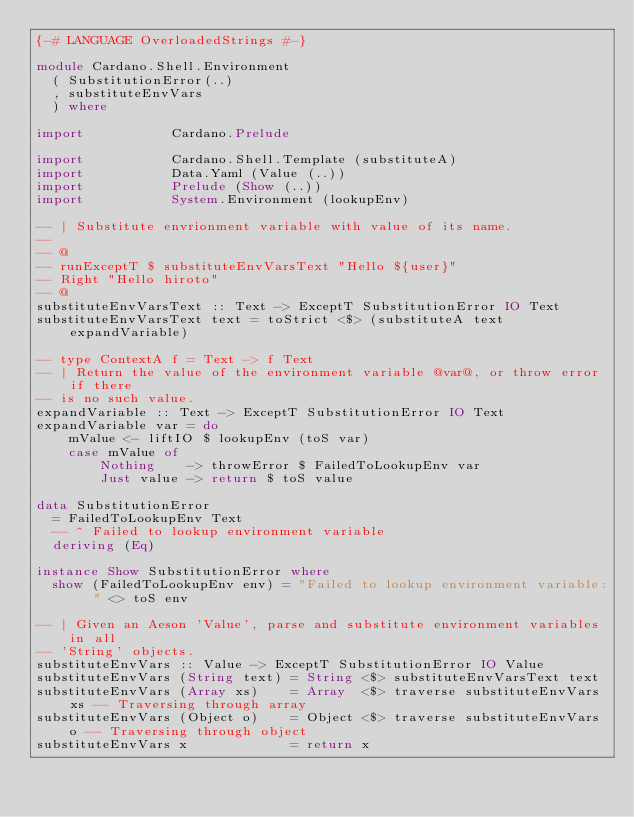Convert code to text. <code><loc_0><loc_0><loc_500><loc_500><_Haskell_>{-# LANGUAGE OverloadedStrings #-}

module Cardano.Shell.Environment
  ( SubstitutionError(..)
  , substituteEnvVars
  ) where

import           Cardano.Prelude

import           Cardano.Shell.Template (substituteA)
import           Data.Yaml (Value (..))
import           Prelude (Show (..))
import           System.Environment (lookupEnv)

-- | Substitute envrionment variable with value of its name.
--
-- @
-- runExceptT $ substituteEnvVarsText "Hello ${user}"
-- Right "Hello hiroto"
-- @
substituteEnvVarsText :: Text -> ExceptT SubstitutionError IO Text
substituteEnvVarsText text = toStrict <$> (substituteA text expandVariable)

-- type ContextA f = Text -> f Text
-- | Return the value of the environment variable @var@, or throw error if there
-- is no such value.
expandVariable :: Text -> ExceptT SubstitutionError IO Text
expandVariable var = do
    mValue <- liftIO $ lookupEnv (toS var)
    case mValue of
        Nothing    -> throwError $ FailedToLookupEnv var
        Just value -> return $ toS value

data SubstitutionError
  = FailedToLookupEnv Text
  -- ^ Failed to lookup environment variable
  deriving (Eq)

instance Show SubstitutionError where
  show (FailedToLookupEnv env) = "Failed to lookup environment variable: " <> toS env

-- | Given an Aeson 'Value', parse and substitute environment variables in all
-- 'String' objects.
substituteEnvVars :: Value -> ExceptT SubstitutionError IO Value
substituteEnvVars (String text) = String <$> substituteEnvVarsText text
substituteEnvVars (Array xs)    = Array  <$> traverse substituteEnvVars xs -- Traversing through array
substituteEnvVars (Object o)    = Object <$> traverse substituteEnvVars o -- Traversing through object
substituteEnvVars x             = return x
</code> 